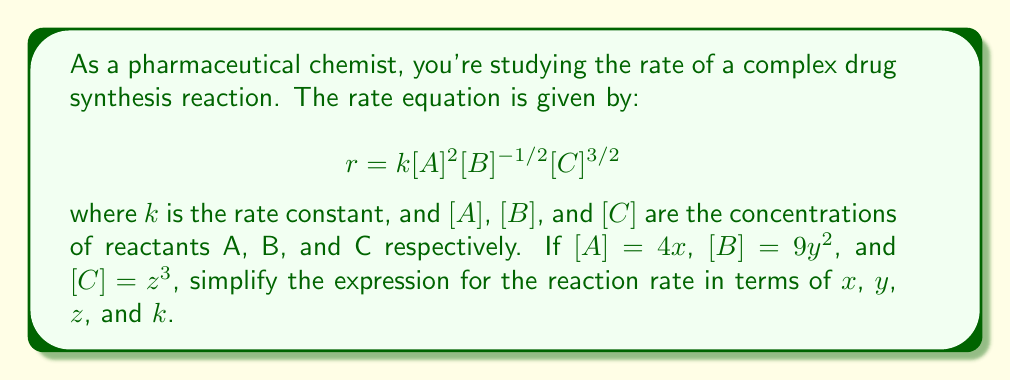Provide a solution to this math problem. Let's approach this step-by-step:

1) First, let's substitute the given expressions for $[A]$, $[B]$, and $[C]$ into the rate equation:

   $$r = k(4x)^2(9y^2)^{-1/2}(z^3)^{3/2}$$

2) Now, let's simplify each term:

   a) $(4x)^2 = 16x^2$
   
   b) $(9y^2)^{-1/2} = \frac{1}{3y}$ (because $(9y^2)^{-1/2} = \frac{1}{(9y^2)^{1/2}} = \frac{1}{3y}$)
   
   c) $(z^3)^{3/2} = z^{9/2}$

3) Substituting these back into the equation:

   $$r = k \cdot 16x^2 \cdot \frac{1}{3y} \cdot z^{9/2}$$

4) Simplify by combining the numerical constants:

   $$r = \frac{16k}{3} \cdot x^2 \cdot y^{-1} \cdot z^{9/2}$$

5) Rearrange to standard form:

   $$r = \frac{16k}{3} \cdot x^2 \cdot z^{9/2} \cdot y^{-1}$$
Answer: $$r = \frac{16k}{3}x^2z^{9/2}y^{-1}$$ 